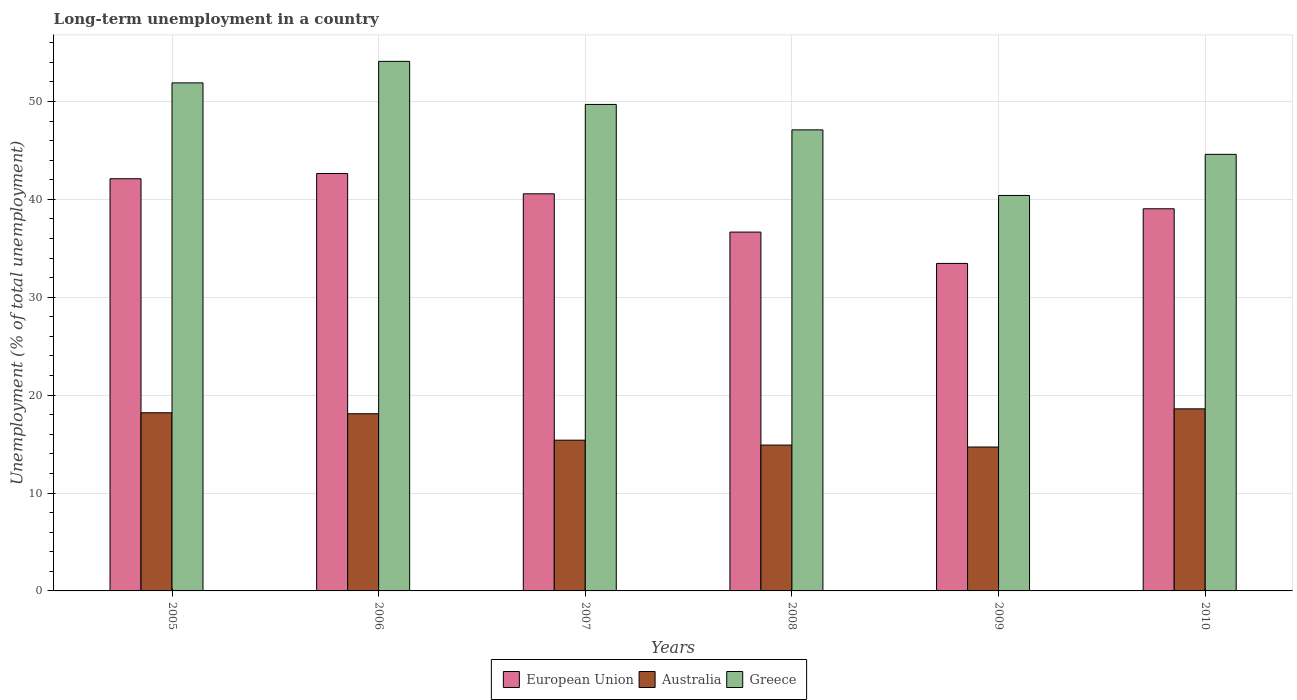How many different coloured bars are there?
Your answer should be very brief. 3. How many groups of bars are there?
Your answer should be very brief. 6. Are the number of bars per tick equal to the number of legend labels?
Your answer should be very brief. Yes. Are the number of bars on each tick of the X-axis equal?
Offer a terse response. Yes. How many bars are there on the 6th tick from the right?
Your answer should be very brief. 3. What is the label of the 5th group of bars from the left?
Provide a succinct answer. 2009. In how many cases, is the number of bars for a given year not equal to the number of legend labels?
Make the answer very short. 0. What is the percentage of long-term unemployed population in Greece in 2008?
Provide a succinct answer. 47.1. Across all years, what is the maximum percentage of long-term unemployed population in Greece?
Keep it short and to the point. 54.1. Across all years, what is the minimum percentage of long-term unemployed population in Greece?
Your answer should be very brief. 40.4. In which year was the percentage of long-term unemployed population in Greece maximum?
Make the answer very short. 2006. What is the total percentage of long-term unemployed population in European Union in the graph?
Offer a terse response. 234.47. What is the difference between the percentage of long-term unemployed population in European Union in 2006 and that in 2009?
Make the answer very short. 9.18. What is the difference between the percentage of long-term unemployed population in Australia in 2009 and the percentage of long-term unemployed population in Greece in 2006?
Your answer should be very brief. -39.4. What is the average percentage of long-term unemployed population in Greece per year?
Keep it short and to the point. 47.97. In the year 2006, what is the difference between the percentage of long-term unemployed population in Australia and percentage of long-term unemployed population in European Union?
Provide a succinct answer. -24.54. In how many years, is the percentage of long-term unemployed population in Australia greater than 42 %?
Your response must be concise. 0. What is the ratio of the percentage of long-term unemployed population in Australia in 2005 to that in 2007?
Offer a very short reply. 1.18. Is the percentage of long-term unemployed population in Greece in 2005 less than that in 2009?
Provide a succinct answer. No. What is the difference between the highest and the second highest percentage of long-term unemployed population in Greece?
Your response must be concise. 2.2. What is the difference between the highest and the lowest percentage of long-term unemployed population in Greece?
Your answer should be compact. 13.7. What does the 1st bar from the left in 2008 represents?
Your answer should be very brief. European Union. Are all the bars in the graph horizontal?
Give a very brief answer. No. How many years are there in the graph?
Ensure brevity in your answer.  6. Does the graph contain any zero values?
Offer a very short reply. No. Does the graph contain grids?
Give a very brief answer. Yes. What is the title of the graph?
Make the answer very short. Long-term unemployment in a country. What is the label or title of the Y-axis?
Provide a short and direct response. Unemployment (% of total unemployment). What is the Unemployment (% of total unemployment) of European Union in 2005?
Provide a short and direct response. 42.11. What is the Unemployment (% of total unemployment) of Australia in 2005?
Offer a very short reply. 18.2. What is the Unemployment (% of total unemployment) in Greece in 2005?
Your answer should be very brief. 51.9. What is the Unemployment (% of total unemployment) in European Union in 2006?
Offer a terse response. 42.64. What is the Unemployment (% of total unemployment) in Australia in 2006?
Your answer should be compact. 18.1. What is the Unemployment (% of total unemployment) in Greece in 2006?
Your answer should be compact. 54.1. What is the Unemployment (% of total unemployment) in European Union in 2007?
Make the answer very short. 40.57. What is the Unemployment (% of total unemployment) in Australia in 2007?
Provide a short and direct response. 15.4. What is the Unemployment (% of total unemployment) of Greece in 2007?
Your answer should be compact. 49.7. What is the Unemployment (% of total unemployment) of European Union in 2008?
Your response must be concise. 36.66. What is the Unemployment (% of total unemployment) in Australia in 2008?
Make the answer very short. 14.9. What is the Unemployment (% of total unemployment) of Greece in 2008?
Offer a very short reply. 47.1. What is the Unemployment (% of total unemployment) of European Union in 2009?
Offer a terse response. 33.46. What is the Unemployment (% of total unemployment) of Australia in 2009?
Make the answer very short. 14.7. What is the Unemployment (% of total unemployment) in Greece in 2009?
Ensure brevity in your answer.  40.4. What is the Unemployment (% of total unemployment) in European Union in 2010?
Your answer should be very brief. 39.04. What is the Unemployment (% of total unemployment) in Australia in 2010?
Provide a succinct answer. 18.6. What is the Unemployment (% of total unemployment) of Greece in 2010?
Keep it short and to the point. 44.6. Across all years, what is the maximum Unemployment (% of total unemployment) of European Union?
Provide a short and direct response. 42.64. Across all years, what is the maximum Unemployment (% of total unemployment) in Australia?
Offer a very short reply. 18.6. Across all years, what is the maximum Unemployment (% of total unemployment) in Greece?
Ensure brevity in your answer.  54.1. Across all years, what is the minimum Unemployment (% of total unemployment) of European Union?
Keep it short and to the point. 33.46. Across all years, what is the minimum Unemployment (% of total unemployment) of Australia?
Ensure brevity in your answer.  14.7. Across all years, what is the minimum Unemployment (% of total unemployment) of Greece?
Your answer should be compact. 40.4. What is the total Unemployment (% of total unemployment) in European Union in the graph?
Keep it short and to the point. 234.47. What is the total Unemployment (% of total unemployment) of Australia in the graph?
Provide a succinct answer. 99.9. What is the total Unemployment (% of total unemployment) of Greece in the graph?
Make the answer very short. 287.8. What is the difference between the Unemployment (% of total unemployment) of European Union in 2005 and that in 2006?
Keep it short and to the point. -0.53. What is the difference between the Unemployment (% of total unemployment) of European Union in 2005 and that in 2007?
Provide a short and direct response. 1.54. What is the difference between the Unemployment (% of total unemployment) of European Union in 2005 and that in 2008?
Ensure brevity in your answer.  5.45. What is the difference between the Unemployment (% of total unemployment) in Greece in 2005 and that in 2008?
Ensure brevity in your answer.  4.8. What is the difference between the Unemployment (% of total unemployment) in European Union in 2005 and that in 2009?
Give a very brief answer. 8.65. What is the difference between the Unemployment (% of total unemployment) of European Union in 2005 and that in 2010?
Keep it short and to the point. 3.07. What is the difference between the Unemployment (% of total unemployment) in Australia in 2005 and that in 2010?
Your answer should be very brief. -0.4. What is the difference between the Unemployment (% of total unemployment) in European Union in 2006 and that in 2007?
Offer a very short reply. 2.07. What is the difference between the Unemployment (% of total unemployment) in European Union in 2006 and that in 2008?
Ensure brevity in your answer.  5.98. What is the difference between the Unemployment (% of total unemployment) of Greece in 2006 and that in 2008?
Ensure brevity in your answer.  7. What is the difference between the Unemployment (% of total unemployment) in European Union in 2006 and that in 2009?
Provide a short and direct response. 9.18. What is the difference between the Unemployment (% of total unemployment) of Greece in 2006 and that in 2009?
Your answer should be compact. 13.7. What is the difference between the Unemployment (% of total unemployment) of European Union in 2006 and that in 2010?
Make the answer very short. 3.6. What is the difference between the Unemployment (% of total unemployment) in Greece in 2006 and that in 2010?
Your response must be concise. 9.5. What is the difference between the Unemployment (% of total unemployment) of European Union in 2007 and that in 2008?
Offer a terse response. 3.91. What is the difference between the Unemployment (% of total unemployment) in Australia in 2007 and that in 2008?
Provide a succinct answer. 0.5. What is the difference between the Unemployment (% of total unemployment) of Greece in 2007 and that in 2008?
Your answer should be compact. 2.6. What is the difference between the Unemployment (% of total unemployment) of European Union in 2007 and that in 2009?
Your answer should be very brief. 7.11. What is the difference between the Unemployment (% of total unemployment) in Australia in 2007 and that in 2009?
Give a very brief answer. 0.7. What is the difference between the Unemployment (% of total unemployment) in European Union in 2007 and that in 2010?
Provide a short and direct response. 1.53. What is the difference between the Unemployment (% of total unemployment) in European Union in 2008 and that in 2009?
Provide a short and direct response. 3.2. What is the difference between the Unemployment (% of total unemployment) of Australia in 2008 and that in 2009?
Provide a succinct answer. 0.2. What is the difference between the Unemployment (% of total unemployment) in European Union in 2008 and that in 2010?
Keep it short and to the point. -2.38. What is the difference between the Unemployment (% of total unemployment) of Australia in 2008 and that in 2010?
Keep it short and to the point. -3.7. What is the difference between the Unemployment (% of total unemployment) of Greece in 2008 and that in 2010?
Make the answer very short. 2.5. What is the difference between the Unemployment (% of total unemployment) in European Union in 2009 and that in 2010?
Offer a terse response. -5.58. What is the difference between the Unemployment (% of total unemployment) of European Union in 2005 and the Unemployment (% of total unemployment) of Australia in 2006?
Your response must be concise. 24.01. What is the difference between the Unemployment (% of total unemployment) in European Union in 2005 and the Unemployment (% of total unemployment) in Greece in 2006?
Ensure brevity in your answer.  -11.99. What is the difference between the Unemployment (% of total unemployment) in Australia in 2005 and the Unemployment (% of total unemployment) in Greece in 2006?
Make the answer very short. -35.9. What is the difference between the Unemployment (% of total unemployment) in European Union in 2005 and the Unemployment (% of total unemployment) in Australia in 2007?
Make the answer very short. 26.71. What is the difference between the Unemployment (% of total unemployment) of European Union in 2005 and the Unemployment (% of total unemployment) of Greece in 2007?
Give a very brief answer. -7.59. What is the difference between the Unemployment (% of total unemployment) in Australia in 2005 and the Unemployment (% of total unemployment) in Greece in 2007?
Offer a very short reply. -31.5. What is the difference between the Unemployment (% of total unemployment) in European Union in 2005 and the Unemployment (% of total unemployment) in Australia in 2008?
Give a very brief answer. 27.21. What is the difference between the Unemployment (% of total unemployment) of European Union in 2005 and the Unemployment (% of total unemployment) of Greece in 2008?
Keep it short and to the point. -4.99. What is the difference between the Unemployment (% of total unemployment) in Australia in 2005 and the Unemployment (% of total unemployment) in Greece in 2008?
Make the answer very short. -28.9. What is the difference between the Unemployment (% of total unemployment) of European Union in 2005 and the Unemployment (% of total unemployment) of Australia in 2009?
Your answer should be compact. 27.41. What is the difference between the Unemployment (% of total unemployment) in European Union in 2005 and the Unemployment (% of total unemployment) in Greece in 2009?
Offer a very short reply. 1.71. What is the difference between the Unemployment (% of total unemployment) in Australia in 2005 and the Unemployment (% of total unemployment) in Greece in 2009?
Offer a terse response. -22.2. What is the difference between the Unemployment (% of total unemployment) in European Union in 2005 and the Unemployment (% of total unemployment) in Australia in 2010?
Keep it short and to the point. 23.51. What is the difference between the Unemployment (% of total unemployment) in European Union in 2005 and the Unemployment (% of total unemployment) in Greece in 2010?
Make the answer very short. -2.49. What is the difference between the Unemployment (% of total unemployment) of Australia in 2005 and the Unemployment (% of total unemployment) of Greece in 2010?
Your answer should be compact. -26.4. What is the difference between the Unemployment (% of total unemployment) of European Union in 2006 and the Unemployment (% of total unemployment) of Australia in 2007?
Keep it short and to the point. 27.24. What is the difference between the Unemployment (% of total unemployment) of European Union in 2006 and the Unemployment (% of total unemployment) of Greece in 2007?
Your response must be concise. -7.06. What is the difference between the Unemployment (% of total unemployment) of Australia in 2006 and the Unemployment (% of total unemployment) of Greece in 2007?
Your answer should be very brief. -31.6. What is the difference between the Unemployment (% of total unemployment) in European Union in 2006 and the Unemployment (% of total unemployment) in Australia in 2008?
Provide a succinct answer. 27.74. What is the difference between the Unemployment (% of total unemployment) of European Union in 2006 and the Unemployment (% of total unemployment) of Greece in 2008?
Provide a succinct answer. -4.46. What is the difference between the Unemployment (% of total unemployment) of Australia in 2006 and the Unemployment (% of total unemployment) of Greece in 2008?
Keep it short and to the point. -29. What is the difference between the Unemployment (% of total unemployment) of European Union in 2006 and the Unemployment (% of total unemployment) of Australia in 2009?
Provide a short and direct response. 27.94. What is the difference between the Unemployment (% of total unemployment) of European Union in 2006 and the Unemployment (% of total unemployment) of Greece in 2009?
Your response must be concise. 2.24. What is the difference between the Unemployment (% of total unemployment) of Australia in 2006 and the Unemployment (% of total unemployment) of Greece in 2009?
Ensure brevity in your answer.  -22.3. What is the difference between the Unemployment (% of total unemployment) of European Union in 2006 and the Unemployment (% of total unemployment) of Australia in 2010?
Your response must be concise. 24.04. What is the difference between the Unemployment (% of total unemployment) in European Union in 2006 and the Unemployment (% of total unemployment) in Greece in 2010?
Make the answer very short. -1.96. What is the difference between the Unemployment (% of total unemployment) in Australia in 2006 and the Unemployment (% of total unemployment) in Greece in 2010?
Your response must be concise. -26.5. What is the difference between the Unemployment (% of total unemployment) in European Union in 2007 and the Unemployment (% of total unemployment) in Australia in 2008?
Keep it short and to the point. 25.67. What is the difference between the Unemployment (% of total unemployment) in European Union in 2007 and the Unemployment (% of total unemployment) in Greece in 2008?
Offer a terse response. -6.53. What is the difference between the Unemployment (% of total unemployment) in Australia in 2007 and the Unemployment (% of total unemployment) in Greece in 2008?
Make the answer very short. -31.7. What is the difference between the Unemployment (% of total unemployment) of European Union in 2007 and the Unemployment (% of total unemployment) of Australia in 2009?
Keep it short and to the point. 25.87. What is the difference between the Unemployment (% of total unemployment) in European Union in 2007 and the Unemployment (% of total unemployment) in Greece in 2009?
Make the answer very short. 0.17. What is the difference between the Unemployment (% of total unemployment) in Australia in 2007 and the Unemployment (% of total unemployment) in Greece in 2009?
Give a very brief answer. -25. What is the difference between the Unemployment (% of total unemployment) of European Union in 2007 and the Unemployment (% of total unemployment) of Australia in 2010?
Provide a short and direct response. 21.97. What is the difference between the Unemployment (% of total unemployment) in European Union in 2007 and the Unemployment (% of total unemployment) in Greece in 2010?
Your answer should be very brief. -4.03. What is the difference between the Unemployment (% of total unemployment) of Australia in 2007 and the Unemployment (% of total unemployment) of Greece in 2010?
Give a very brief answer. -29.2. What is the difference between the Unemployment (% of total unemployment) in European Union in 2008 and the Unemployment (% of total unemployment) in Australia in 2009?
Offer a terse response. 21.96. What is the difference between the Unemployment (% of total unemployment) of European Union in 2008 and the Unemployment (% of total unemployment) of Greece in 2009?
Your answer should be very brief. -3.74. What is the difference between the Unemployment (% of total unemployment) in Australia in 2008 and the Unemployment (% of total unemployment) in Greece in 2009?
Give a very brief answer. -25.5. What is the difference between the Unemployment (% of total unemployment) of European Union in 2008 and the Unemployment (% of total unemployment) of Australia in 2010?
Offer a terse response. 18.06. What is the difference between the Unemployment (% of total unemployment) of European Union in 2008 and the Unemployment (% of total unemployment) of Greece in 2010?
Your response must be concise. -7.94. What is the difference between the Unemployment (% of total unemployment) in Australia in 2008 and the Unemployment (% of total unemployment) in Greece in 2010?
Make the answer very short. -29.7. What is the difference between the Unemployment (% of total unemployment) in European Union in 2009 and the Unemployment (% of total unemployment) in Australia in 2010?
Provide a short and direct response. 14.86. What is the difference between the Unemployment (% of total unemployment) in European Union in 2009 and the Unemployment (% of total unemployment) in Greece in 2010?
Make the answer very short. -11.14. What is the difference between the Unemployment (% of total unemployment) in Australia in 2009 and the Unemployment (% of total unemployment) in Greece in 2010?
Offer a very short reply. -29.9. What is the average Unemployment (% of total unemployment) of European Union per year?
Your answer should be compact. 39.08. What is the average Unemployment (% of total unemployment) of Australia per year?
Give a very brief answer. 16.65. What is the average Unemployment (% of total unemployment) in Greece per year?
Your answer should be very brief. 47.97. In the year 2005, what is the difference between the Unemployment (% of total unemployment) in European Union and Unemployment (% of total unemployment) in Australia?
Provide a succinct answer. 23.91. In the year 2005, what is the difference between the Unemployment (% of total unemployment) of European Union and Unemployment (% of total unemployment) of Greece?
Offer a very short reply. -9.79. In the year 2005, what is the difference between the Unemployment (% of total unemployment) of Australia and Unemployment (% of total unemployment) of Greece?
Your response must be concise. -33.7. In the year 2006, what is the difference between the Unemployment (% of total unemployment) of European Union and Unemployment (% of total unemployment) of Australia?
Offer a very short reply. 24.54. In the year 2006, what is the difference between the Unemployment (% of total unemployment) of European Union and Unemployment (% of total unemployment) of Greece?
Offer a very short reply. -11.46. In the year 2006, what is the difference between the Unemployment (% of total unemployment) in Australia and Unemployment (% of total unemployment) in Greece?
Your answer should be very brief. -36. In the year 2007, what is the difference between the Unemployment (% of total unemployment) of European Union and Unemployment (% of total unemployment) of Australia?
Provide a short and direct response. 25.17. In the year 2007, what is the difference between the Unemployment (% of total unemployment) in European Union and Unemployment (% of total unemployment) in Greece?
Your answer should be very brief. -9.13. In the year 2007, what is the difference between the Unemployment (% of total unemployment) of Australia and Unemployment (% of total unemployment) of Greece?
Offer a very short reply. -34.3. In the year 2008, what is the difference between the Unemployment (% of total unemployment) in European Union and Unemployment (% of total unemployment) in Australia?
Provide a short and direct response. 21.76. In the year 2008, what is the difference between the Unemployment (% of total unemployment) of European Union and Unemployment (% of total unemployment) of Greece?
Provide a short and direct response. -10.44. In the year 2008, what is the difference between the Unemployment (% of total unemployment) in Australia and Unemployment (% of total unemployment) in Greece?
Provide a short and direct response. -32.2. In the year 2009, what is the difference between the Unemployment (% of total unemployment) of European Union and Unemployment (% of total unemployment) of Australia?
Your answer should be compact. 18.76. In the year 2009, what is the difference between the Unemployment (% of total unemployment) of European Union and Unemployment (% of total unemployment) of Greece?
Offer a very short reply. -6.94. In the year 2009, what is the difference between the Unemployment (% of total unemployment) of Australia and Unemployment (% of total unemployment) of Greece?
Your answer should be very brief. -25.7. In the year 2010, what is the difference between the Unemployment (% of total unemployment) in European Union and Unemployment (% of total unemployment) in Australia?
Keep it short and to the point. 20.44. In the year 2010, what is the difference between the Unemployment (% of total unemployment) in European Union and Unemployment (% of total unemployment) in Greece?
Offer a terse response. -5.56. What is the ratio of the Unemployment (% of total unemployment) in European Union in 2005 to that in 2006?
Keep it short and to the point. 0.99. What is the ratio of the Unemployment (% of total unemployment) of Greece in 2005 to that in 2006?
Ensure brevity in your answer.  0.96. What is the ratio of the Unemployment (% of total unemployment) in European Union in 2005 to that in 2007?
Give a very brief answer. 1.04. What is the ratio of the Unemployment (% of total unemployment) of Australia in 2005 to that in 2007?
Provide a short and direct response. 1.18. What is the ratio of the Unemployment (% of total unemployment) in Greece in 2005 to that in 2007?
Your answer should be compact. 1.04. What is the ratio of the Unemployment (% of total unemployment) in European Union in 2005 to that in 2008?
Provide a short and direct response. 1.15. What is the ratio of the Unemployment (% of total unemployment) in Australia in 2005 to that in 2008?
Provide a succinct answer. 1.22. What is the ratio of the Unemployment (% of total unemployment) of Greece in 2005 to that in 2008?
Ensure brevity in your answer.  1.1. What is the ratio of the Unemployment (% of total unemployment) in European Union in 2005 to that in 2009?
Make the answer very short. 1.26. What is the ratio of the Unemployment (% of total unemployment) of Australia in 2005 to that in 2009?
Provide a short and direct response. 1.24. What is the ratio of the Unemployment (% of total unemployment) of Greece in 2005 to that in 2009?
Keep it short and to the point. 1.28. What is the ratio of the Unemployment (% of total unemployment) of European Union in 2005 to that in 2010?
Your response must be concise. 1.08. What is the ratio of the Unemployment (% of total unemployment) of Australia in 2005 to that in 2010?
Provide a succinct answer. 0.98. What is the ratio of the Unemployment (% of total unemployment) of Greece in 2005 to that in 2010?
Give a very brief answer. 1.16. What is the ratio of the Unemployment (% of total unemployment) of European Union in 2006 to that in 2007?
Offer a terse response. 1.05. What is the ratio of the Unemployment (% of total unemployment) in Australia in 2006 to that in 2007?
Your answer should be very brief. 1.18. What is the ratio of the Unemployment (% of total unemployment) in Greece in 2006 to that in 2007?
Your answer should be very brief. 1.09. What is the ratio of the Unemployment (% of total unemployment) in European Union in 2006 to that in 2008?
Offer a terse response. 1.16. What is the ratio of the Unemployment (% of total unemployment) in Australia in 2006 to that in 2008?
Offer a terse response. 1.21. What is the ratio of the Unemployment (% of total unemployment) of Greece in 2006 to that in 2008?
Keep it short and to the point. 1.15. What is the ratio of the Unemployment (% of total unemployment) in European Union in 2006 to that in 2009?
Provide a succinct answer. 1.27. What is the ratio of the Unemployment (% of total unemployment) of Australia in 2006 to that in 2009?
Make the answer very short. 1.23. What is the ratio of the Unemployment (% of total unemployment) of Greece in 2006 to that in 2009?
Your answer should be very brief. 1.34. What is the ratio of the Unemployment (% of total unemployment) in European Union in 2006 to that in 2010?
Provide a succinct answer. 1.09. What is the ratio of the Unemployment (% of total unemployment) in Australia in 2006 to that in 2010?
Give a very brief answer. 0.97. What is the ratio of the Unemployment (% of total unemployment) of Greece in 2006 to that in 2010?
Your answer should be compact. 1.21. What is the ratio of the Unemployment (% of total unemployment) in European Union in 2007 to that in 2008?
Your answer should be very brief. 1.11. What is the ratio of the Unemployment (% of total unemployment) of Australia in 2007 to that in 2008?
Keep it short and to the point. 1.03. What is the ratio of the Unemployment (% of total unemployment) of Greece in 2007 to that in 2008?
Provide a succinct answer. 1.06. What is the ratio of the Unemployment (% of total unemployment) of European Union in 2007 to that in 2009?
Give a very brief answer. 1.21. What is the ratio of the Unemployment (% of total unemployment) of Australia in 2007 to that in 2009?
Offer a terse response. 1.05. What is the ratio of the Unemployment (% of total unemployment) in Greece in 2007 to that in 2009?
Make the answer very short. 1.23. What is the ratio of the Unemployment (% of total unemployment) in European Union in 2007 to that in 2010?
Provide a short and direct response. 1.04. What is the ratio of the Unemployment (% of total unemployment) of Australia in 2007 to that in 2010?
Keep it short and to the point. 0.83. What is the ratio of the Unemployment (% of total unemployment) in Greece in 2007 to that in 2010?
Your answer should be compact. 1.11. What is the ratio of the Unemployment (% of total unemployment) in European Union in 2008 to that in 2009?
Your answer should be very brief. 1.1. What is the ratio of the Unemployment (% of total unemployment) of Australia in 2008 to that in 2009?
Provide a succinct answer. 1.01. What is the ratio of the Unemployment (% of total unemployment) of Greece in 2008 to that in 2009?
Make the answer very short. 1.17. What is the ratio of the Unemployment (% of total unemployment) of European Union in 2008 to that in 2010?
Your answer should be compact. 0.94. What is the ratio of the Unemployment (% of total unemployment) of Australia in 2008 to that in 2010?
Your answer should be very brief. 0.8. What is the ratio of the Unemployment (% of total unemployment) in Greece in 2008 to that in 2010?
Keep it short and to the point. 1.06. What is the ratio of the Unemployment (% of total unemployment) in European Union in 2009 to that in 2010?
Give a very brief answer. 0.86. What is the ratio of the Unemployment (% of total unemployment) of Australia in 2009 to that in 2010?
Provide a succinct answer. 0.79. What is the ratio of the Unemployment (% of total unemployment) of Greece in 2009 to that in 2010?
Your response must be concise. 0.91. What is the difference between the highest and the second highest Unemployment (% of total unemployment) in European Union?
Your response must be concise. 0.53. What is the difference between the highest and the second highest Unemployment (% of total unemployment) in Australia?
Provide a short and direct response. 0.4. What is the difference between the highest and the lowest Unemployment (% of total unemployment) of European Union?
Provide a short and direct response. 9.18. What is the difference between the highest and the lowest Unemployment (% of total unemployment) of Australia?
Your answer should be very brief. 3.9. 